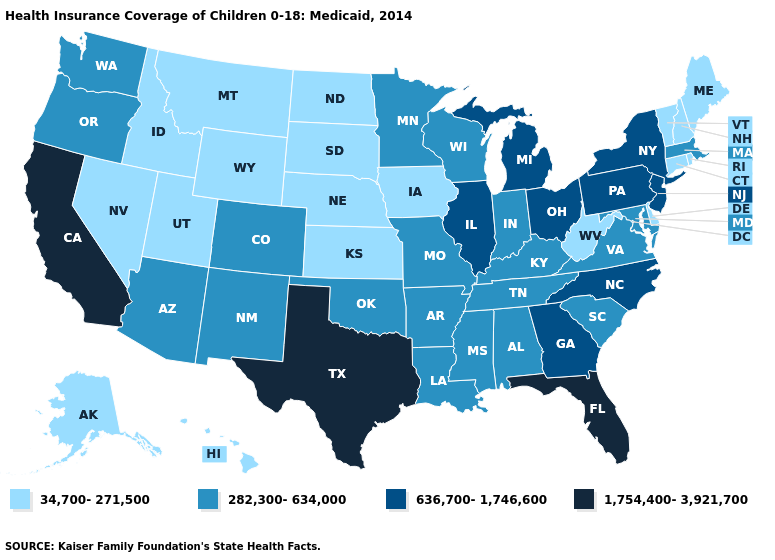Does California have the highest value in the West?
Write a very short answer. Yes. What is the value of North Dakota?
Give a very brief answer. 34,700-271,500. Among the states that border Vermont , does New Hampshire have the lowest value?
Answer briefly. Yes. What is the value of Kansas?
Be succinct. 34,700-271,500. Name the states that have a value in the range 636,700-1,746,600?
Keep it brief. Georgia, Illinois, Michigan, New Jersey, New York, North Carolina, Ohio, Pennsylvania. What is the highest value in the USA?
Write a very short answer. 1,754,400-3,921,700. Among the states that border Illinois , which have the highest value?
Quick response, please. Indiana, Kentucky, Missouri, Wisconsin. What is the highest value in the USA?
Give a very brief answer. 1,754,400-3,921,700. Name the states that have a value in the range 1,754,400-3,921,700?
Be succinct. California, Florida, Texas. Does Tennessee have the lowest value in the USA?
Quick response, please. No. Does Michigan have the highest value in the MidWest?
Quick response, please. Yes. How many symbols are there in the legend?
Keep it brief. 4. What is the lowest value in states that border Pennsylvania?
Write a very short answer. 34,700-271,500. What is the lowest value in the MidWest?
Answer briefly. 34,700-271,500. What is the lowest value in the USA?
Concise answer only. 34,700-271,500. 